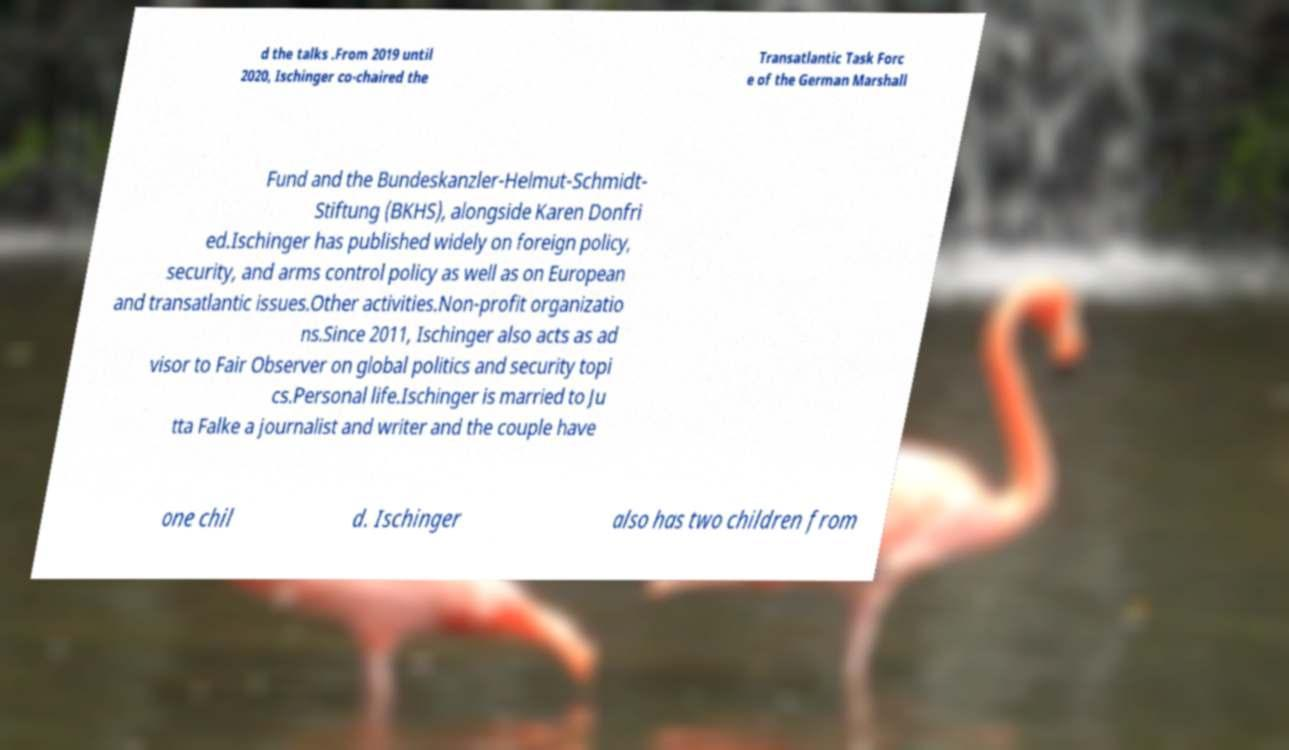Could you extract and type out the text from this image? d the talks .From 2019 until 2020, Ischinger co-chaired the Transatlantic Task Forc e of the German Marshall Fund and the Bundeskanzler-Helmut-Schmidt- Stiftung (BKHS), alongside Karen Donfri ed.Ischinger has published widely on foreign policy, security, and arms control policy as well as on European and transatlantic issues.Other activities.Non-profit organizatio ns.Since 2011, Ischinger also acts as ad visor to Fair Observer on global politics and security topi cs.Personal life.Ischinger is married to Ju tta Falke a journalist and writer and the couple have one chil d. Ischinger also has two children from 